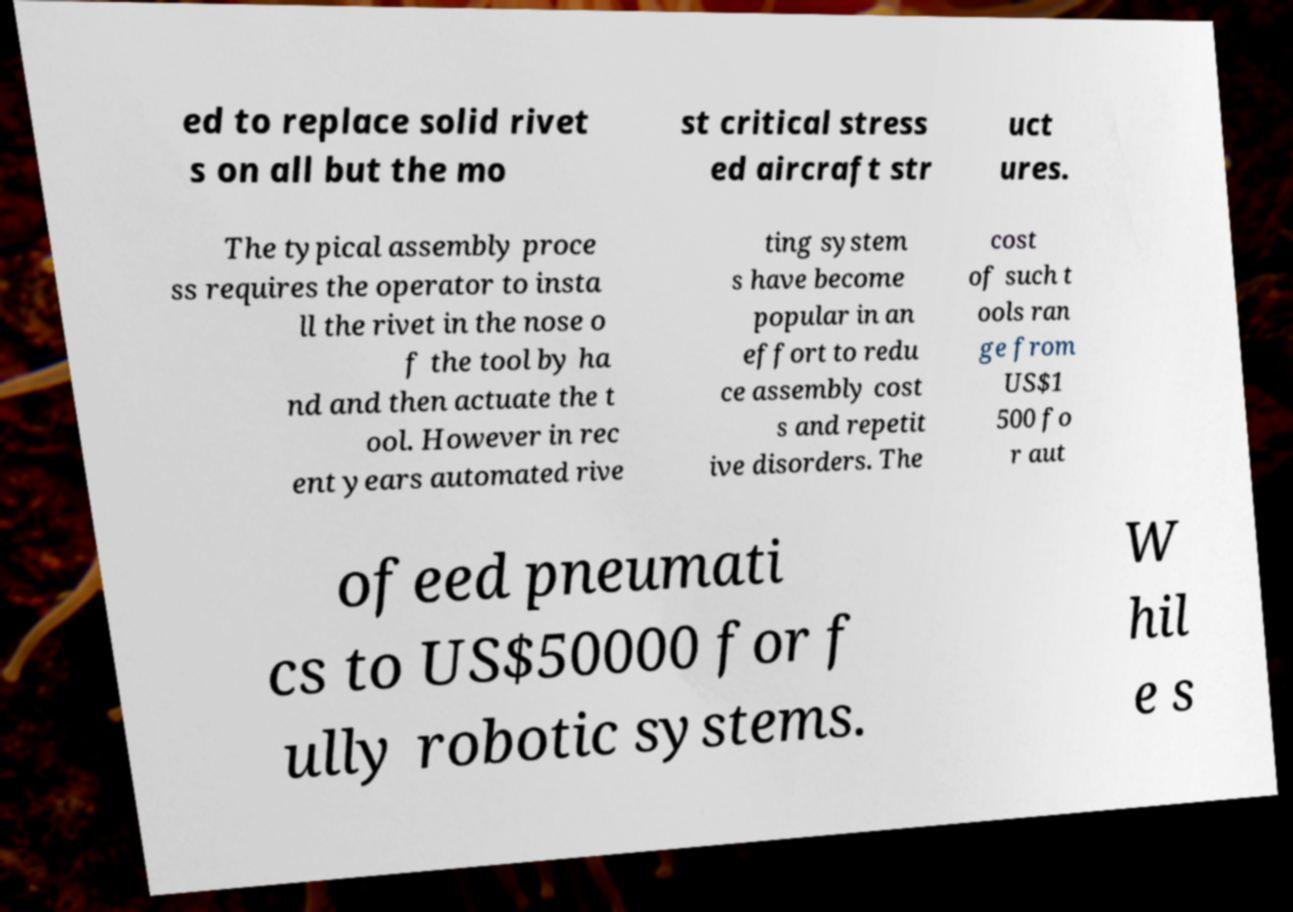There's text embedded in this image that I need extracted. Can you transcribe it verbatim? ed to replace solid rivet s on all but the mo st critical stress ed aircraft str uct ures. The typical assembly proce ss requires the operator to insta ll the rivet in the nose o f the tool by ha nd and then actuate the t ool. However in rec ent years automated rive ting system s have become popular in an effort to redu ce assembly cost s and repetit ive disorders. The cost of such t ools ran ge from US$1 500 fo r aut ofeed pneumati cs to US$50000 for f ully robotic systems. W hil e s 